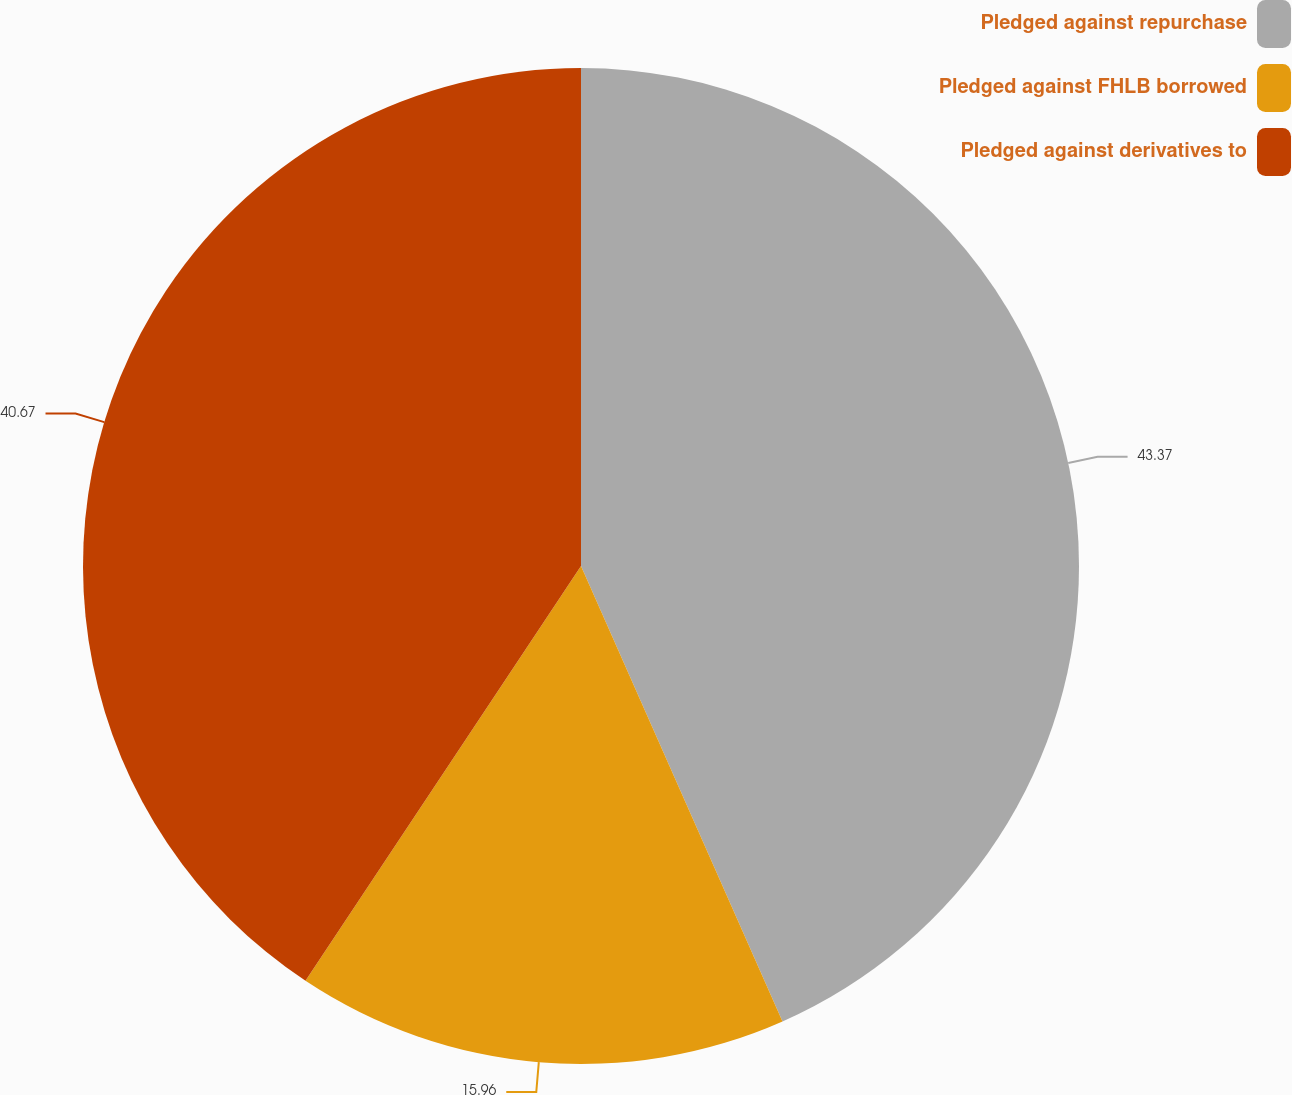Convert chart. <chart><loc_0><loc_0><loc_500><loc_500><pie_chart><fcel>Pledged against repurchase<fcel>Pledged against FHLB borrowed<fcel>Pledged against derivatives to<nl><fcel>43.37%<fcel>15.96%<fcel>40.67%<nl></chart> 